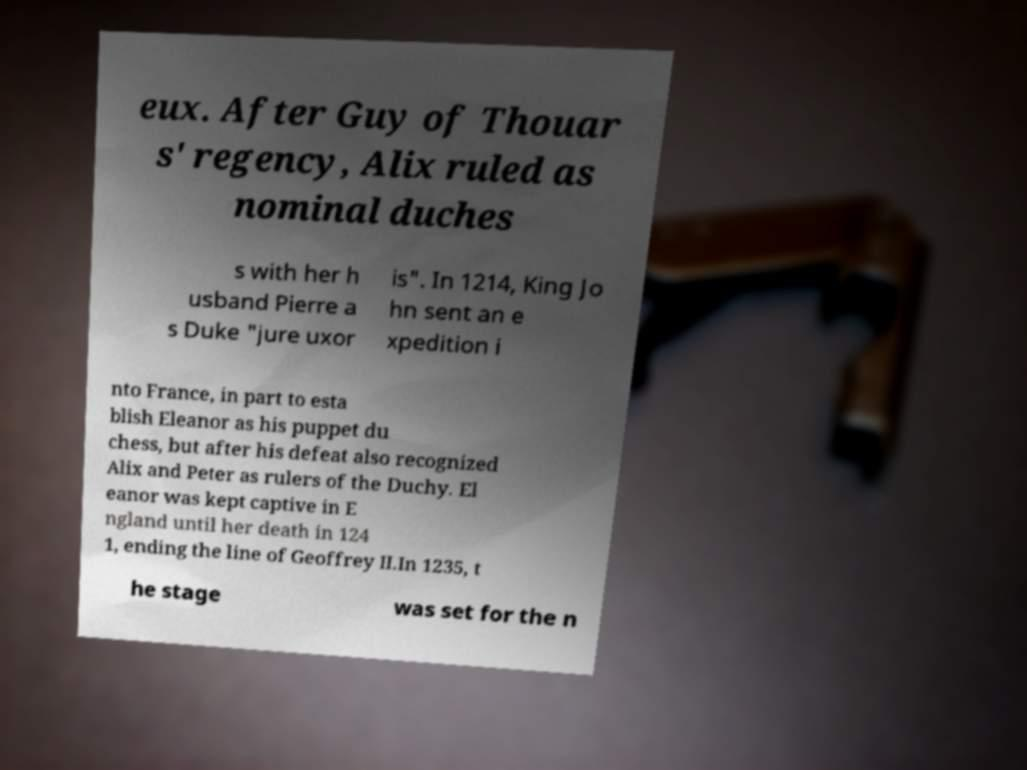What messages or text are displayed in this image? I need them in a readable, typed format. eux. After Guy of Thouar s' regency, Alix ruled as nominal duches s with her h usband Pierre a s Duke "jure uxor is". In 1214, King Jo hn sent an e xpedition i nto France, in part to esta blish Eleanor as his puppet du chess, but after his defeat also recognized Alix and Peter as rulers of the Duchy. El eanor was kept captive in E ngland until her death in 124 1, ending the line of Geoffrey II.In 1235, t he stage was set for the n 